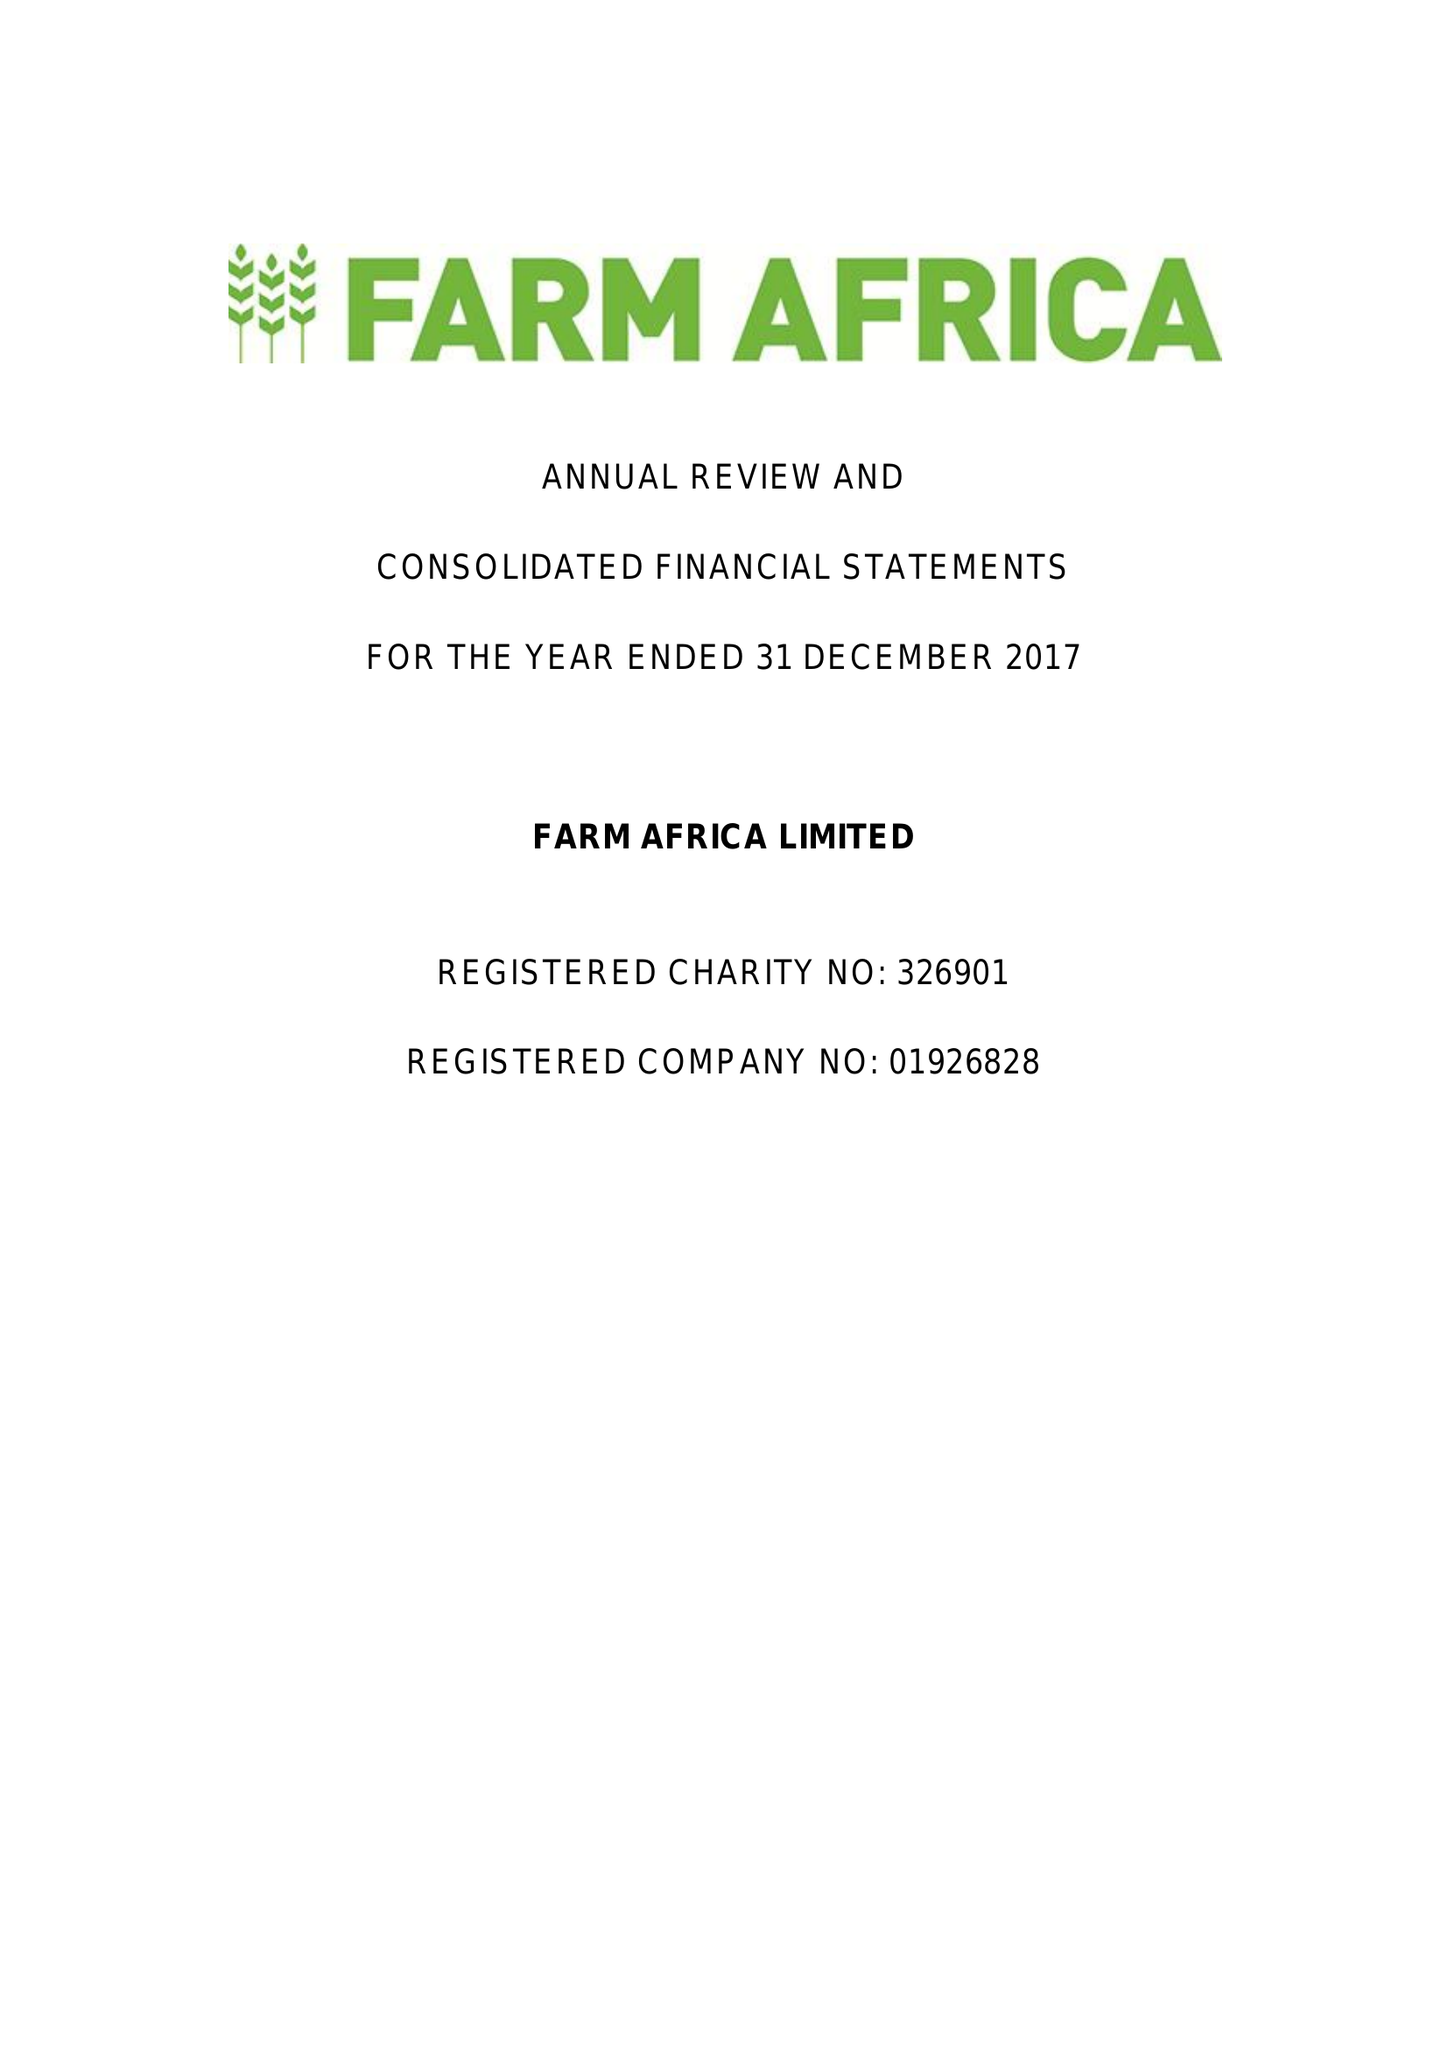What is the value for the charity_number?
Answer the question using a single word or phrase. 326901 